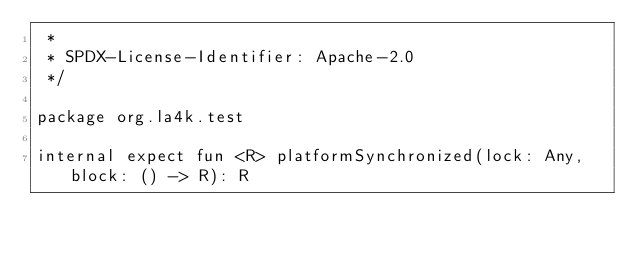<code> <loc_0><loc_0><loc_500><loc_500><_Kotlin_> *
 * SPDX-License-Identifier: Apache-2.0
 */

package org.la4k.test

internal expect fun <R> platformSynchronized(lock: Any, block: () -> R): R
</code> 